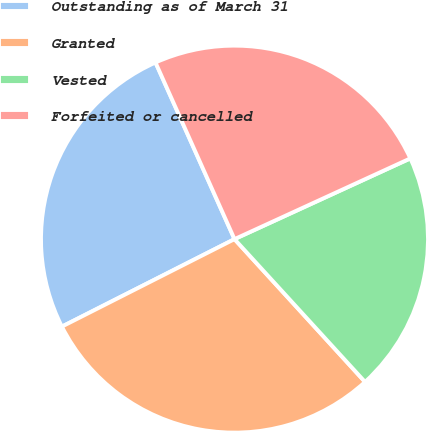Convert chart. <chart><loc_0><loc_0><loc_500><loc_500><pie_chart><fcel>Outstanding as of March 31<fcel>Granted<fcel>Vested<fcel>Forfeited or cancelled<nl><fcel>25.77%<fcel>29.32%<fcel>20.06%<fcel>24.84%<nl></chart> 